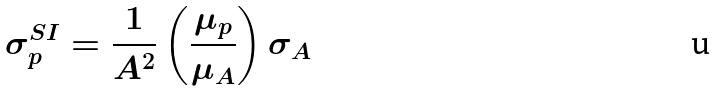Convert formula to latex. <formula><loc_0><loc_0><loc_500><loc_500>\sigma _ { p } ^ { S I } = \frac { 1 } { A ^ { 2 } } \left ( \frac { \mu _ { p } } { \mu _ { A } } \right ) \sigma _ { A }</formula> 